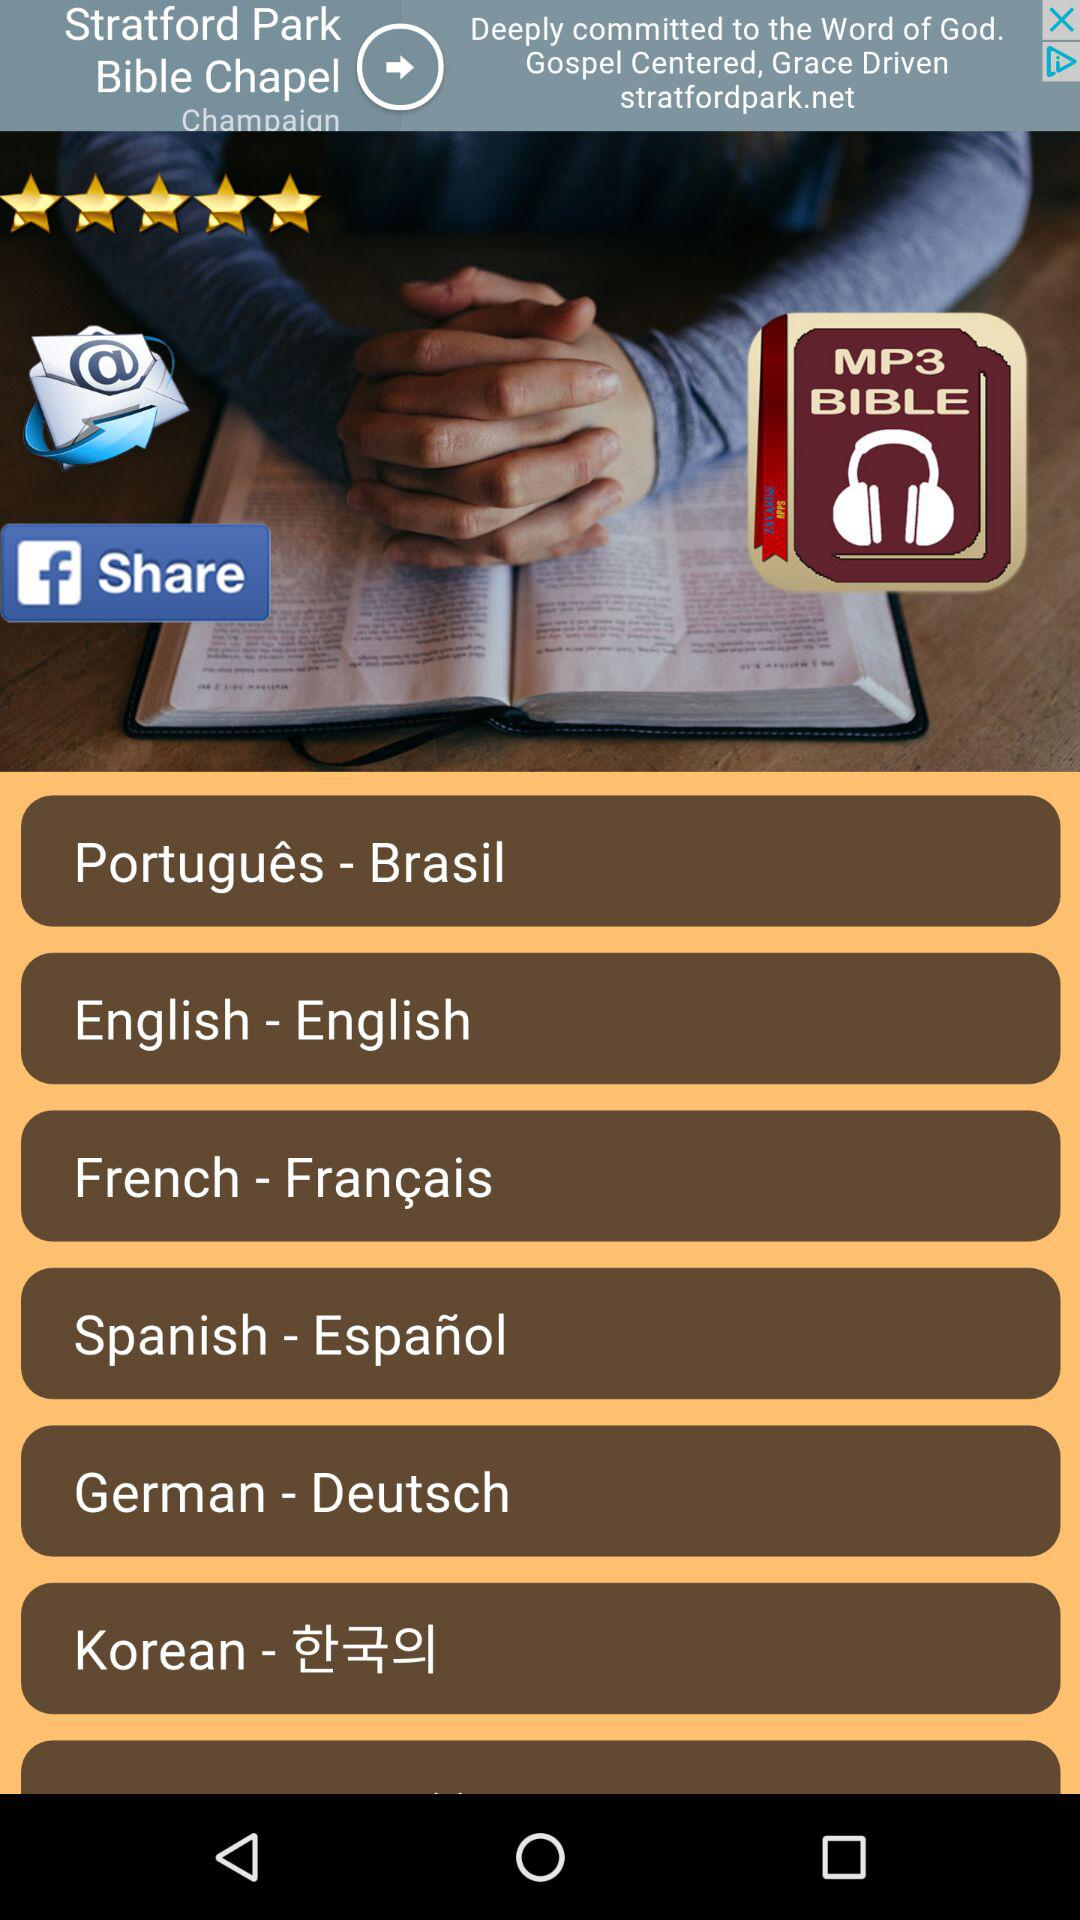In which language is the "Bible" available? The "Bible" is available in Português, English, French, Spanish, German and Korean. 